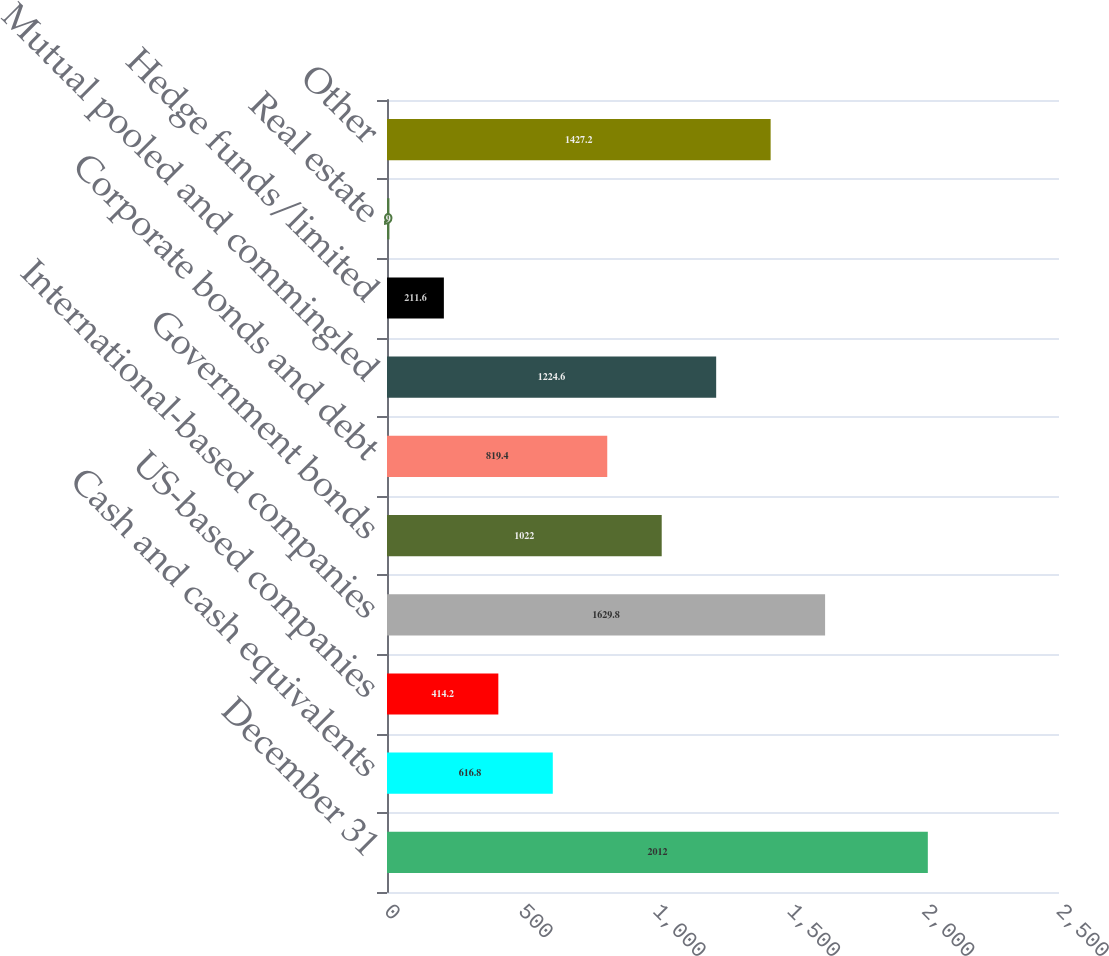<chart> <loc_0><loc_0><loc_500><loc_500><bar_chart><fcel>December 31<fcel>Cash and cash equivalents<fcel>US-based companies<fcel>International-based companies<fcel>Government bonds<fcel>Corporate bonds and debt<fcel>Mutual pooled and commingled<fcel>Hedge funds/limited<fcel>Real estate<fcel>Other<nl><fcel>2012<fcel>616.8<fcel>414.2<fcel>1629.8<fcel>1022<fcel>819.4<fcel>1224.6<fcel>211.6<fcel>9<fcel>1427.2<nl></chart> 